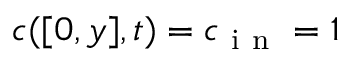<formula> <loc_0><loc_0><loc_500><loc_500>c ( [ 0 , y ] , t ) = c _ { i n } = 1</formula> 